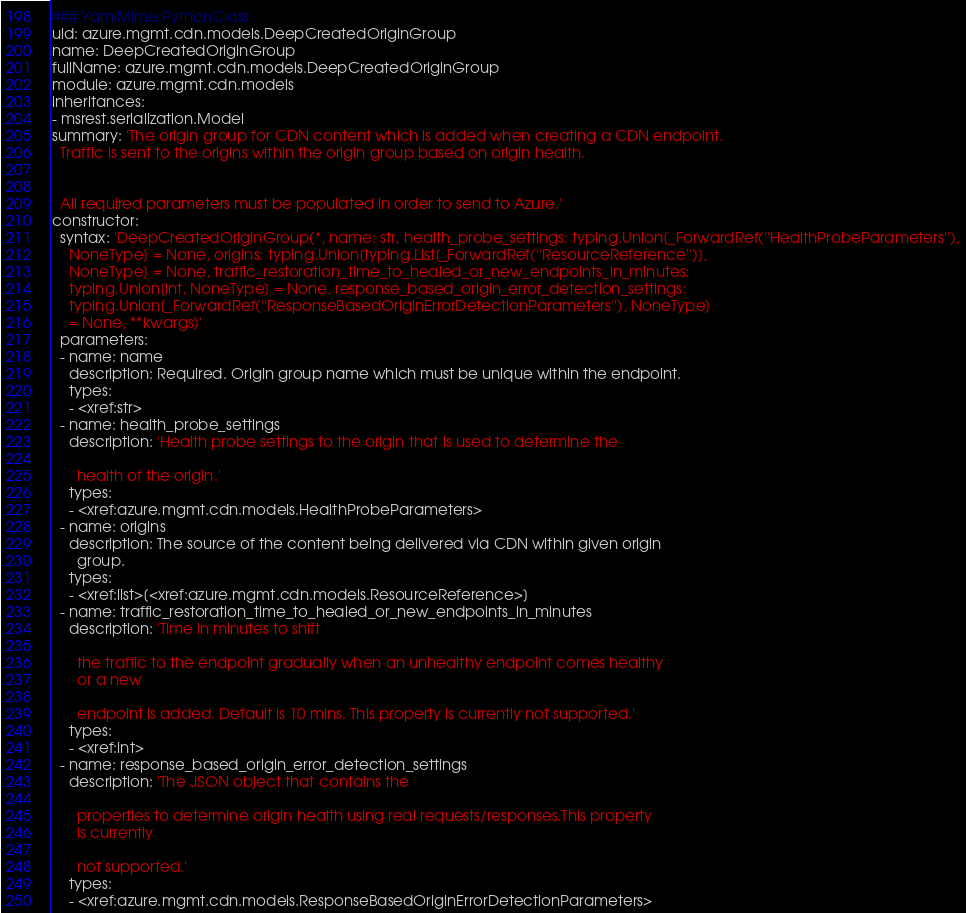<code> <loc_0><loc_0><loc_500><loc_500><_YAML_>### YamlMime:PythonClass
uid: azure.mgmt.cdn.models.DeepCreatedOriginGroup
name: DeepCreatedOriginGroup
fullName: azure.mgmt.cdn.models.DeepCreatedOriginGroup
module: azure.mgmt.cdn.models
inheritances:
- msrest.serialization.Model
summary: 'The origin group for CDN content which is added when creating a CDN endpoint.
  Traffic is sent to the origins within the origin group based on origin health.


  All required parameters must be populated in order to send to Azure.'
constructor:
  syntax: 'DeepCreatedOriginGroup(*, name: str, health_probe_settings: typing.Union[_ForwardRef(''HealthProbeParameters''),
    NoneType] = None, origins: typing.Union[typing.List[_ForwardRef(''ResourceReference'')],
    NoneType] = None, traffic_restoration_time_to_healed_or_new_endpoints_in_minutes:
    typing.Union[int, NoneType] = None, response_based_origin_error_detection_settings:
    typing.Union[_ForwardRef(''ResponseBasedOriginErrorDetectionParameters''), NoneType]
    = None, **kwargs)'
  parameters:
  - name: name
    description: Required. Origin group name which must be unique within the endpoint.
    types:
    - <xref:str>
  - name: health_probe_settings
    description: 'Health probe settings to the origin that is used to determine the

      health of the origin.'
    types:
    - <xref:azure.mgmt.cdn.models.HealthProbeParameters>
  - name: origins
    description: The source of the content being delivered via CDN within given origin
      group.
    types:
    - <xref:list>[<xref:azure.mgmt.cdn.models.ResourceReference>]
  - name: traffic_restoration_time_to_healed_or_new_endpoints_in_minutes
    description: 'Time in minutes to shift

      the traffic to the endpoint gradually when an unhealthy endpoint comes healthy
      or a new

      endpoint is added. Default is 10 mins. This property is currently not supported.'
    types:
    - <xref:int>
  - name: response_based_origin_error_detection_settings
    description: 'The JSON object that contains the

      properties to determine origin health using real requests/responses.This property
      is currently

      not supported.'
    types:
    - <xref:azure.mgmt.cdn.models.ResponseBasedOriginErrorDetectionParameters>
</code> 